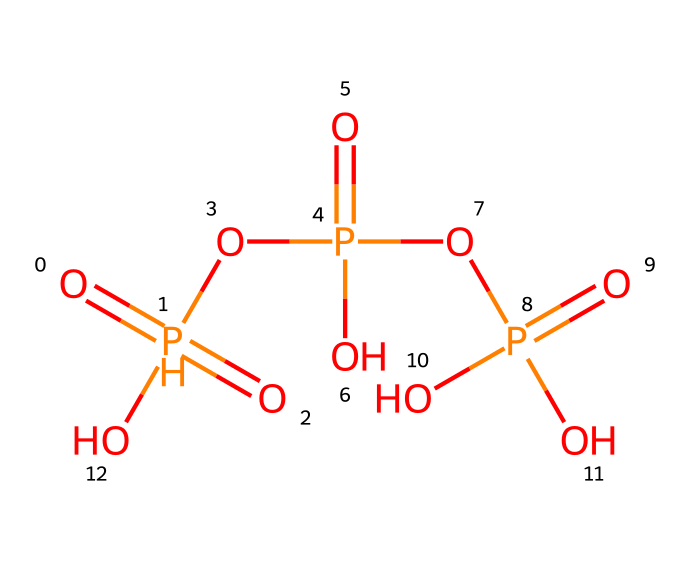What is the total number of phosphorus atoms in this chemical? The chemical formula representation shows multiple phosphate groups. Analyzing the SMILES, we recognize there are three distinct sections containing phosphorus (P).
Answer: three How many oxygen atoms are present in this chemical? Each phosphorus atom is associated with multiple oxygen atoms. Counting the oxygen atoms linked throughout the molecule in the SMILES, we find there are a total of six oxygen atoms.
Answer: six What type of functional groups are present in this chemical? The presence of multiple P=O (phosphoryl) and O-P (phosphate) connections in the structure indicates that this compound is a phosphoric anhydride, which consists primarily of acid anhydrides.
Answer: phosphoric anhydride What is the oxidation state of phosphorus in this compound? Each phosphorus atom in the anhydride state generally has an oxidation state of +5, indicated by the presence of double-bonded oxygen in a phosphate context.
Answer: +5 Is this compound likely to be acidic or basic in nature? Given that it is a phosphoric anhydride, which tends to donate protons in solution, the characteristics of the structure suggest it has acidic properties.
Answer: acidic 